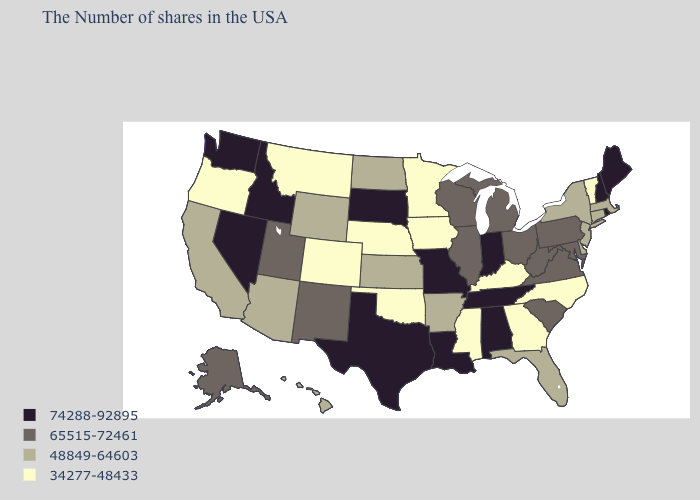Does the map have missing data?
Write a very short answer. No. Name the states that have a value in the range 65515-72461?
Give a very brief answer. Maryland, Pennsylvania, Virginia, South Carolina, West Virginia, Ohio, Michigan, Wisconsin, Illinois, New Mexico, Utah, Alaska. Which states have the lowest value in the USA?
Quick response, please. Vermont, North Carolina, Georgia, Kentucky, Mississippi, Minnesota, Iowa, Nebraska, Oklahoma, Colorado, Montana, Oregon. Among the states that border Wyoming , does Colorado have the lowest value?
Be succinct. Yes. Does the map have missing data?
Write a very short answer. No. Does the first symbol in the legend represent the smallest category?
Give a very brief answer. No. Name the states that have a value in the range 65515-72461?
Write a very short answer. Maryland, Pennsylvania, Virginia, South Carolina, West Virginia, Ohio, Michigan, Wisconsin, Illinois, New Mexico, Utah, Alaska. Name the states that have a value in the range 48849-64603?
Short answer required. Massachusetts, Connecticut, New York, New Jersey, Delaware, Florida, Arkansas, Kansas, North Dakota, Wyoming, Arizona, California, Hawaii. Does South Carolina have the same value as Oregon?
Write a very short answer. No. Is the legend a continuous bar?
Short answer required. No. What is the value of Arizona?
Keep it brief. 48849-64603. Does New Mexico have a higher value than South Dakota?
Short answer required. No. Among the states that border Massachusetts , does Vermont have the highest value?
Answer briefly. No. What is the value of Alaska?
Give a very brief answer. 65515-72461. Name the states that have a value in the range 48849-64603?
Short answer required. Massachusetts, Connecticut, New York, New Jersey, Delaware, Florida, Arkansas, Kansas, North Dakota, Wyoming, Arizona, California, Hawaii. 